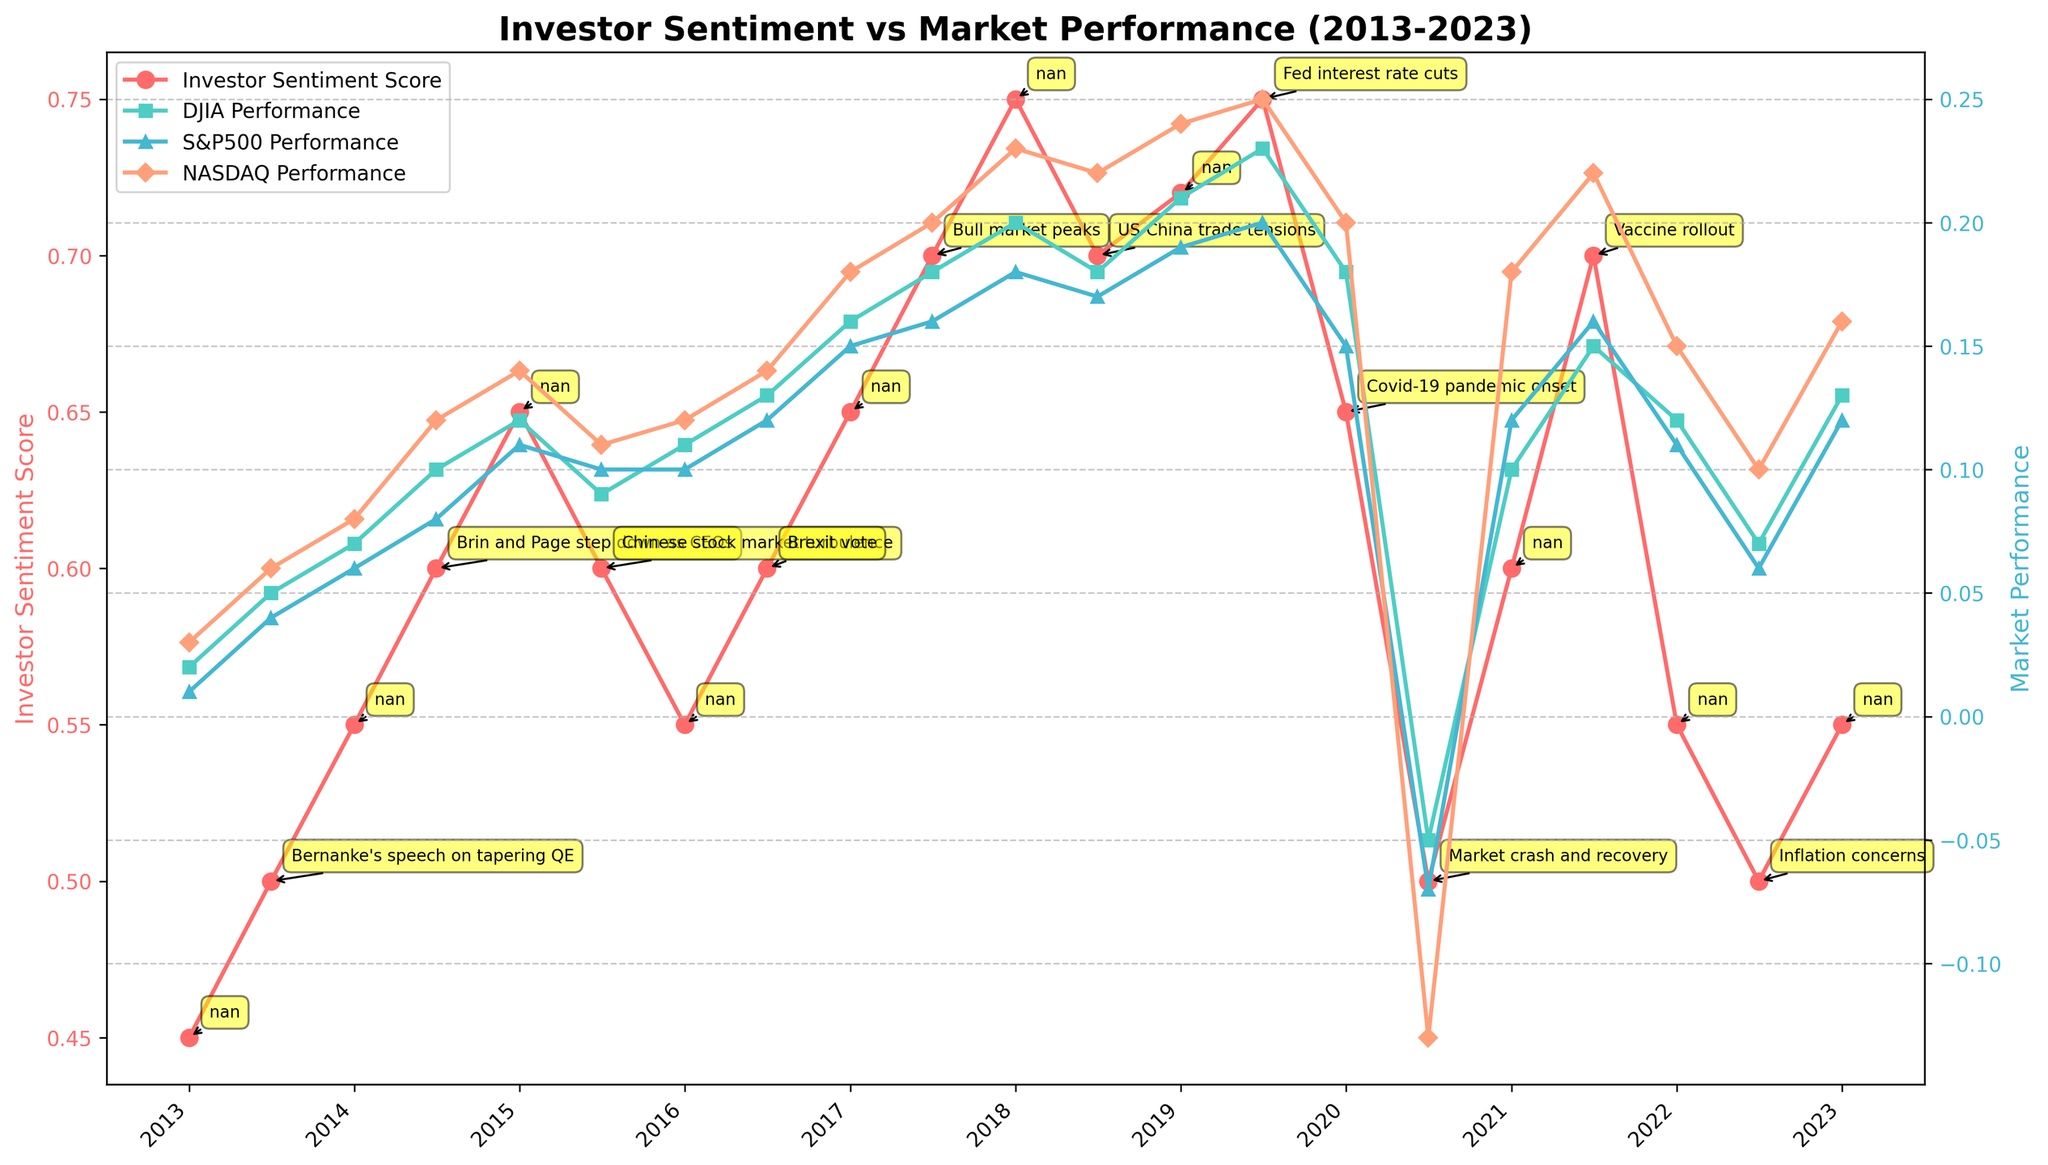What is the title of the figure? The title of the figure is usually located at the top of the plot. Here, the title is clearly stated in large, bold font at the top of the plot.
Answer: Investor Sentiment vs Market Performance (2013-2023) How many lines are plotted in the figure? The plot includes multiple lines for various metrics. By examining the figure, we can count the total number of distinct lines.
Answer: 4 What color is used for the Investor Sentiment Score line? The color of the line representing the Investor Sentiment Score is apparent by looking at its distinct appearance and matching it with the legend.
Answer: Red Which notable event occurred around January 2020, and how did it affect the Investor Sentiment Score? Look at the data point around January 2020 and read the annotation for the notable event. Then observe any significant changes in the Investor Sentiment Score.
Answer: Covid-19 pandemic onset, decreased from 0.72 to 0.65 How did the DJIA Performance change during the Covid-19 pandemic onset? Identify the time frame for the Covid-19 pandemic onset in January 2020 and observe the change in the DJIA Performance from the previous period to this period.
Answer: Decreased from 0.23 to 0.18 What is the general trend of the Investor Sentiment Score over the ten-year period? Observe the overall movement of the Investor Sentiment Score line from the start to the end of the ten-year period.
Answer: Generally increasing Which market index showed the highest performance during July 2021? Examine the data points for July 2021 and compare the markers representing DJIA, S&P500, and NASDAQ Performance to find the highest value.
Answer: NASDAQ Performance When did the Investor Sentiment Score experience a significant drop, and which notable event coincided with this drop? Look for sharp declines in the Investor Sentiment Score line and read the annotations that coincide with these points.
Answer: July 2020, Market crash and recovery Compare the Investor Sentiment Score with DJIA Performance in mid-2020. How do they relate? Examine the values for both Investor Sentiment Score and DJIA Performance around mid-2020. Identify any common trends or patterns.
Answer: Both decreased significantly What notable event coincided with the spike in Investor Sentiment Score in July 2017, and what was its approximate value? Observe July 2017 on the time axis, read the annotation for the notable event, and look at the data point value for the Investor Sentiment Score.
Answer: Bull market peaks, 0.70 